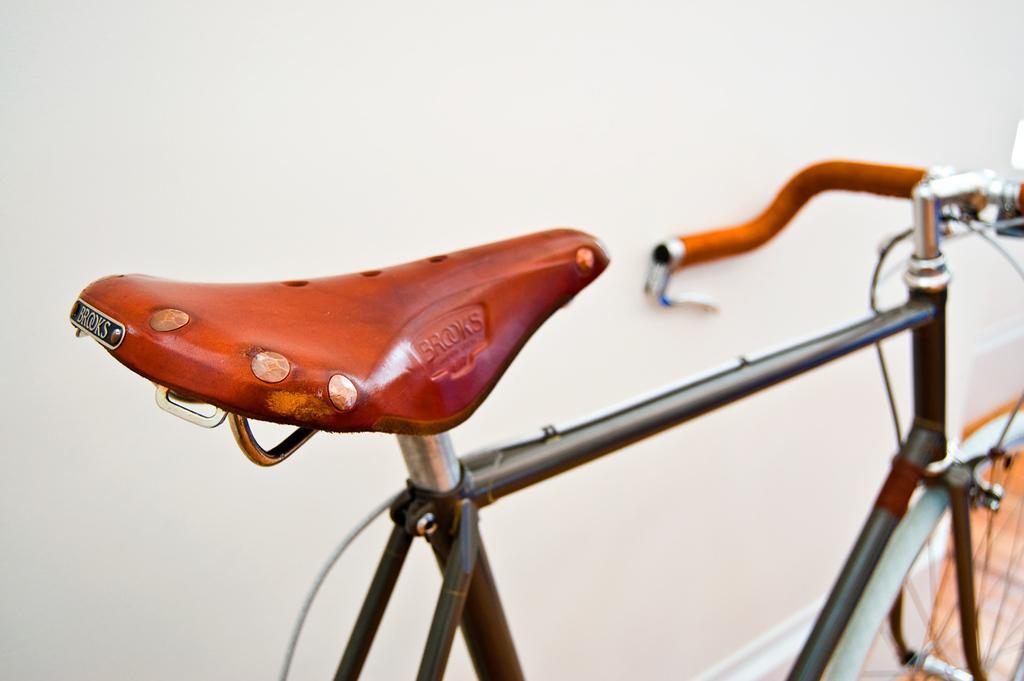In one or two sentences, can you explain what this image depicts? In this image there is a bicycle and a wall. 